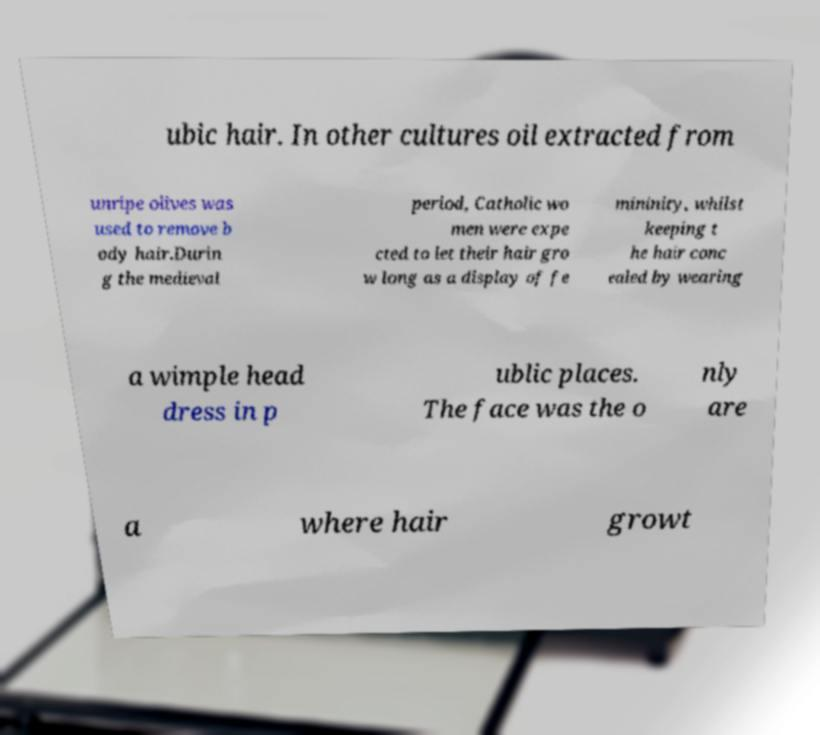What messages or text are displayed in this image? I need them in a readable, typed format. ubic hair. In other cultures oil extracted from unripe olives was used to remove b ody hair.Durin g the medieval period, Catholic wo men were expe cted to let their hair gro w long as a display of fe mininity, whilst keeping t he hair conc ealed by wearing a wimple head dress in p ublic places. The face was the o nly are a where hair growt 